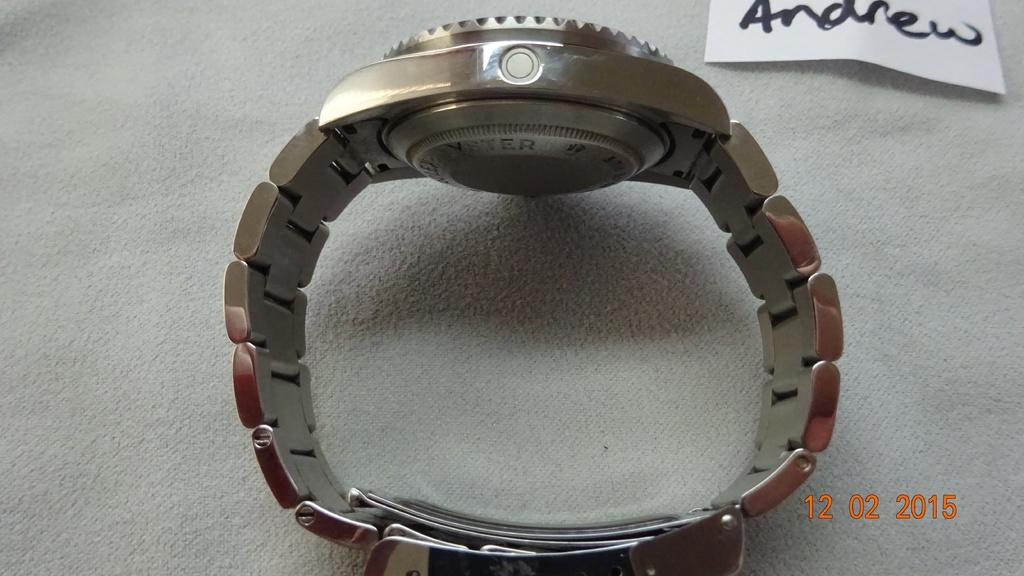<image>
Relay a brief, clear account of the picture shown. A silver watch with a slip of paper next to it that reads Andrew. 